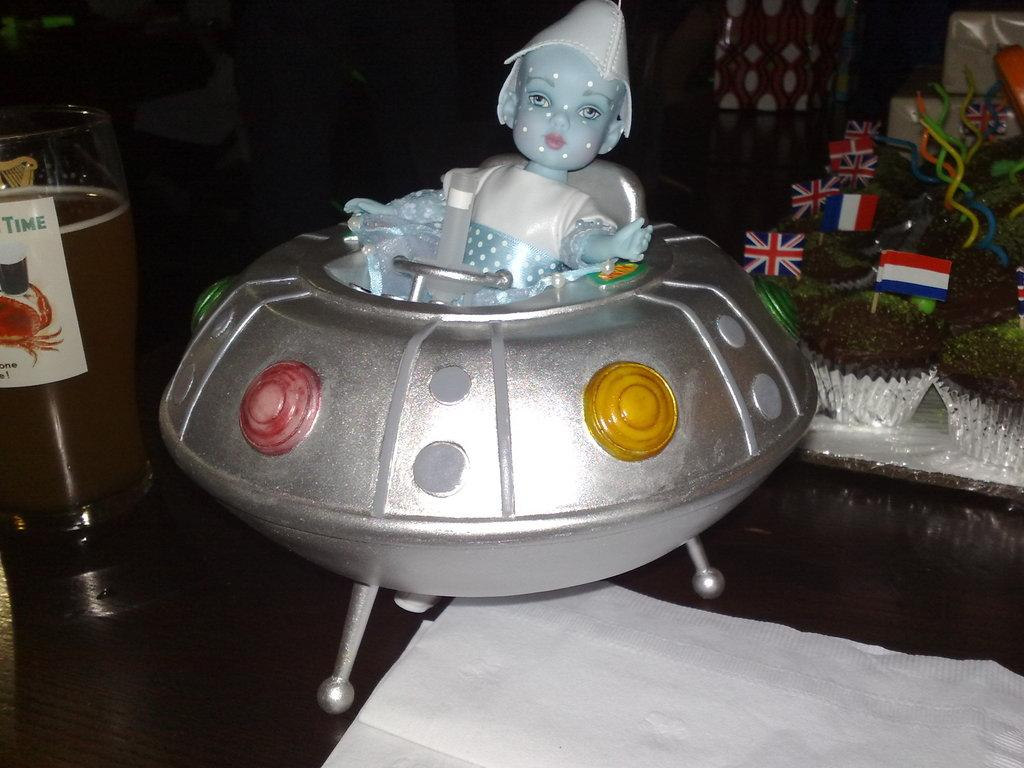What type of object can be seen in the image? There is a toy in the image. What other item is present in the image? There is a paper in the image. Can you describe the contents of a container in the image? There is a glass with liquid in the image. What can be found on the right side of the image? There are objects on the right side of the image. What decorative elements are present in the image? There are flags in the image. What degree of temperature is the liquid in the glass? The provided facts do not mention the temperature of the liquid in the glass, so it cannot be determined from the image. 